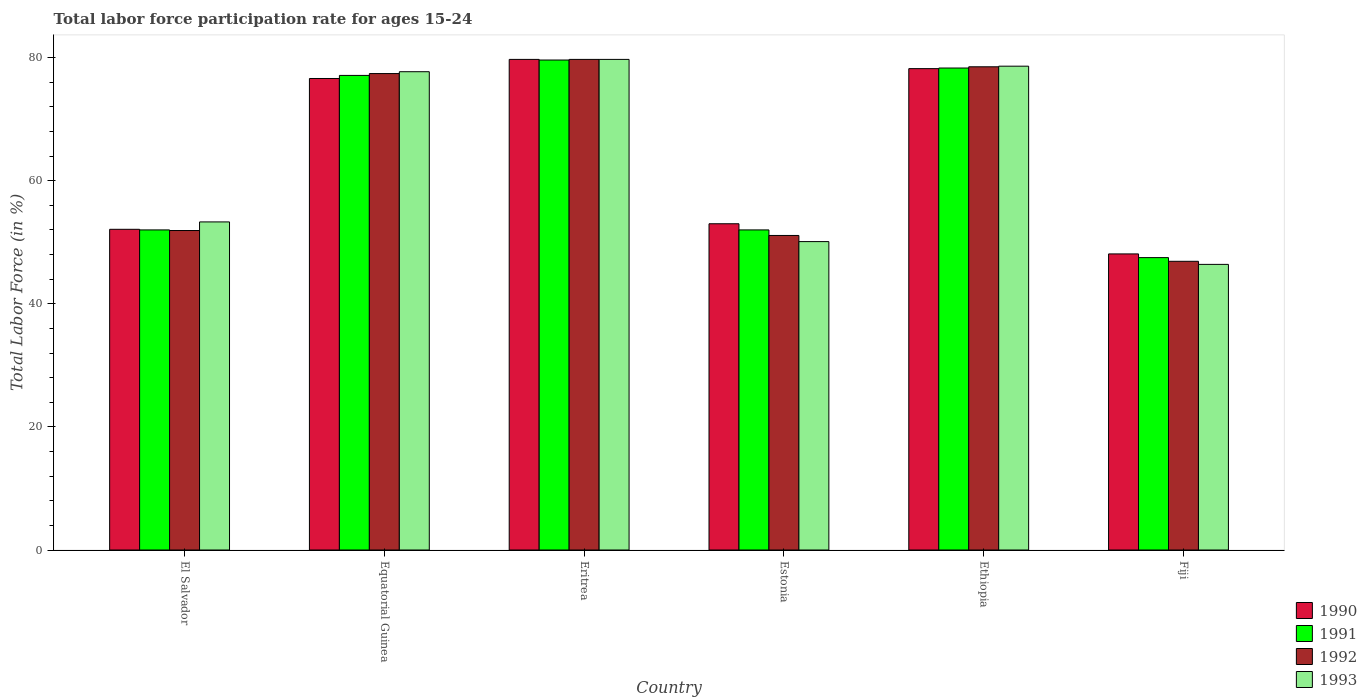How many different coloured bars are there?
Ensure brevity in your answer.  4. How many groups of bars are there?
Keep it short and to the point. 6. How many bars are there on the 1st tick from the left?
Offer a terse response. 4. How many bars are there on the 1st tick from the right?
Offer a very short reply. 4. What is the label of the 3rd group of bars from the left?
Offer a very short reply. Eritrea. In how many cases, is the number of bars for a given country not equal to the number of legend labels?
Provide a short and direct response. 0. What is the labor force participation rate in 1991 in Equatorial Guinea?
Your answer should be compact. 77.1. Across all countries, what is the maximum labor force participation rate in 1992?
Provide a short and direct response. 79.7. Across all countries, what is the minimum labor force participation rate in 1993?
Keep it short and to the point. 46.4. In which country was the labor force participation rate in 1992 maximum?
Make the answer very short. Eritrea. In which country was the labor force participation rate in 1993 minimum?
Provide a succinct answer. Fiji. What is the total labor force participation rate in 1990 in the graph?
Keep it short and to the point. 387.7. What is the difference between the labor force participation rate in 1993 in Equatorial Guinea and that in Fiji?
Provide a succinct answer. 31.3. What is the difference between the labor force participation rate in 1991 in Estonia and the labor force participation rate in 1993 in Equatorial Guinea?
Your response must be concise. -25.7. What is the average labor force participation rate in 1992 per country?
Keep it short and to the point. 64.25. What is the difference between the labor force participation rate of/in 1990 and labor force participation rate of/in 1993 in Eritrea?
Offer a terse response. 0. What is the ratio of the labor force participation rate in 1990 in Estonia to that in Ethiopia?
Your response must be concise. 0.68. Is the labor force participation rate in 1990 in El Salvador less than that in Estonia?
Your answer should be compact. Yes. What is the difference between the highest and the second highest labor force participation rate in 1990?
Provide a short and direct response. -1.6. What is the difference between the highest and the lowest labor force participation rate in 1993?
Offer a terse response. 33.3. Is the sum of the labor force participation rate in 1993 in Eritrea and Estonia greater than the maximum labor force participation rate in 1992 across all countries?
Your answer should be compact. Yes. Is it the case that in every country, the sum of the labor force participation rate in 1993 and labor force participation rate in 1991 is greater than the sum of labor force participation rate in 1990 and labor force participation rate in 1992?
Ensure brevity in your answer.  No. What does the 4th bar from the left in Fiji represents?
Offer a very short reply. 1993. Does the graph contain grids?
Provide a short and direct response. No. Where does the legend appear in the graph?
Give a very brief answer. Bottom right. How many legend labels are there?
Your answer should be very brief. 4. What is the title of the graph?
Offer a very short reply. Total labor force participation rate for ages 15-24. Does "1975" appear as one of the legend labels in the graph?
Your answer should be very brief. No. What is the label or title of the X-axis?
Keep it short and to the point. Country. What is the label or title of the Y-axis?
Keep it short and to the point. Total Labor Force (in %). What is the Total Labor Force (in %) of 1990 in El Salvador?
Your answer should be very brief. 52.1. What is the Total Labor Force (in %) in 1991 in El Salvador?
Your answer should be compact. 52. What is the Total Labor Force (in %) of 1992 in El Salvador?
Your response must be concise. 51.9. What is the Total Labor Force (in %) in 1993 in El Salvador?
Offer a terse response. 53.3. What is the Total Labor Force (in %) in 1990 in Equatorial Guinea?
Make the answer very short. 76.6. What is the Total Labor Force (in %) of 1991 in Equatorial Guinea?
Offer a terse response. 77.1. What is the Total Labor Force (in %) in 1992 in Equatorial Guinea?
Give a very brief answer. 77.4. What is the Total Labor Force (in %) of 1993 in Equatorial Guinea?
Your answer should be very brief. 77.7. What is the Total Labor Force (in %) in 1990 in Eritrea?
Provide a short and direct response. 79.7. What is the Total Labor Force (in %) of 1991 in Eritrea?
Your response must be concise. 79.6. What is the Total Labor Force (in %) of 1992 in Eritrea?
Your answer should be compact. 79.7. What is the Total Labor Force (in %) of 1993 in Eritrea?
Provide a succinct answer. 79.7. What is the Total Labor Force (in %) in 1992 in Estonia?
Offer a very short reply. 51.1. What is the Total Labor Force (in %) of 1993 in Estonia?
Your response must be concise. 50.1. What is the Total Labor Force (in %) of 1990 in Ethiopia?
Your response must be concise. 78.2. What is the Total Labor Force (in %) of 1991 in Ethiopia?
Make the answer very short. 78.3. What is the Total Labor Force (in %) in 1992 in Ethiopia?
Give a very brief answer. 78.5. What is the Total Labor Force (in %) of 1993 in Ethiopia?
Offer a terse response. 78.6. What is the Total Labor Force (in %) of 1990 in Fiji?
Give a very brief answer. 48.1. What is the Total Labor Force (in %) of 1991 in Fiji?
Provide a short and direct response. 47.5. What is the Total Labor Force (in %) in 1992 in Fiji?
Your answer should be very brief. 46.9. What is the Total Labor Force (in %) of 1993 in Fiji?
Provide a succinct answer. 46.4. Across all countries, what is the maximum Total Labor Force (in %) of 1990?
Make the answer very short. 79.7. Across all countries, what is the maximum Total Labor Force (in %) in 1991?
Your response must be concise. 79.6. Across all countries, what is the maximum Total Labor Force (in %) of 1992?
Offer a terse response. 79.7. Across all countries, what is the maximum Total Labor Force (in %) of 1993?
Provide a short and direct response. 79.7. Across all countries, what is the minimum Total Labor Force (in %) in 1990?
Make the answer very short. 48.1. Across all countries, what is the minimum Total Labor Force (in %) in 1991?
Your answer should be very brief. 47.5. Across all countries, what is the minimum Total Labor Force (in %) in 1992?
Offer a very short reply. 46.9. Across all countries, what is the minimum Total Labor Force (in %) of 1993?
Ensure brevity in your answer.  46.4. What is the total Total Labor Force (in %) in 1990 in the graph?
Keep it short and to the point. 387.7. What is the total Total Labor Force (in %) in 1991 in the graph?
Ensure brevity in your answer.  386.5. What is the total Total Labor Force (in %) of 1992 in the graph?
Ensure brevity in your answer.  385.5. What is the total Total Labor Force (in %) of 1993 in the graph?
Your answer should be very brief. 385.8. What is the difference between the Total Labor Force (in %) in 1990 in El Salvador and that in Equatorial Guinea?
Your answer should be very brief. -24.5. What is the difference between the Total Labor Force (in %) in 1991 in El Salvador and that in Equatorial Guinea?
Keep it short and to the point. -25.1. What is the difference between the Total Labor Force (in %) in 1992 in El Salvador and that in Equatorial Guinea?
Give a very brief answer. -25.5. What is the difference between the Total Labor Force (in %) in 1993 in El Salvador and that in Equatorial Guinea?
Provide a short and direct response. -24.4. What is the difference between the Total Labor Force (in %) in 1990 in El Salvador and that in Eritrea?
Offer a very short reply. -27.6. What is the difference between the Total Labor Force (in %) in 1991 in El Salvador and that in Eritrea?
Make the answer very short. -27.6. What is the difference between the Total Labor Force (in %) in 1992 in El Salvador and that in Eritrea?
Your answer should be compact. -27.8. What is the difference between the Total Labor Force (in %) of 1993 in El Salvador and that in Eritrea?
Offer a very short reply. -26.4. What is the difference between the Total Labor Force (in %) of 1990 in El Salvador and that in Estonia?
Give a very brief answer. -0.9. What is the difference between the Total Labor Force (in %) in 1991 in El Salvador and that in Estonia?
Keep it short and to the point. 0. What is the difference between the Total Labor Force (in %) of 1990 in El Salvador and that in Ethiopia?
Provide a short and direct response. -26.1. What is the difference between the Total Labor Force (in %) of 1991 in El Salvador and that in Ethiopia?
Give a very brief answer. -26.3. What is the difference between the Total Labor Force (in %) in 1992 in El Salvador and that in Ethiopia?
Give a very brief answer. -26.6. What is the difference between the Total Labor Force (in %) of 1993 in El Salvador and that in Ethiopia?
Give a very brief answer. -25.3. What is the difference between the Total Labor Force (in %) of 1991 in El Salvador and that in Fiji?
Your response must be concise. 4.5. What is the difference between the Total Labor Force (in %) of 1990 in Equatorial Guinea and that in Eritrea?
Ensure brevity in your answer.  -3.1. What is the difference between the Total Labor Force (in %) in 1991 in Equatorial Guinea and that in Eritrea?
Make the answer very short. -2.5. What is the difference between the Total Labor Force (in %) of 1992 in Equatorial Guinea and that in Eritrea?
Make the answer very short. -2.3. What is the difference between the Total Labor Force (in %) of 1993 in Equatorial Guinea and that in Eritrea?
Your response must be concise. -2. What is the difference between the Total Labor Force (in %) of 1990 in Equatorial Guinea and that in Estonia?
Keep it short and to the point. 23.6. What is the difference between the Total Labor Force (in %) in 1991 in Equatorial Guinea and that in Estonia?
Your response must be concise. 25.1. What is the difference between the Total Labor Force (in %) in 1992 in Equatorial Guinea and that in Estonia?
Ensure brevity in your answer.  26.3. What is the difference between the Total Labor Force (in %) in 1993 in Equatorial Guinea and that in Estonia?
Ensure brevity in your answer.  27.6. What is the difference between the Total Labor Force (in %) in 1990 in Equatorial Guinea and that in Ethiopia?
Provide a succinct answer. -1.6. What is the difference between the Total Labor Force (in %) of 1992 in Equatorial Guinea and that in Ethiopia?
Provide a short and direct response. -1.1. What is the difference between the Total Labor Force (in %) of 1991 in Equatorial Guinea and that in Fiji?
Give a very brief answer. 29.6. What is the difference between the Total Labor Force (in %) of 1992 in Equatorial Guinea and that in Fiji?
Offer a terse response. 30.5. What is the difference between the Total Labor Force (in %) in 1993 in Equatorial Guinea and that in Fiji?
Offer a very short reply. 31.3. What is the difference between the Total Labor Force (in %) in 1990 in Eritrea and that in Estonia?
Your response must be concise. 26.7. What is the difference between the Total Labor Force (in %) of 1991 in Eritrea and that in Estonia?
Make the answer very short. 27.6. What is the difference between the Total Labor Force (in %) of 1992 in Eritrea and that in Estonia?
Your answer should be compact. 28.6. What is the difference between the Total Labor Force (in %) of 1993 in Eritrea and that in Estonia?
Your answer should be compact. 29.6. What is the difference between the Total Labor Force (in %) in 1991 in Eritrea and that in Ethiopia?
Give a very brief answer. 1.3. What is the difference between the Total Labor Force (in %) in 1993 in Eritrea and that in Ethiopia?
Give a very brief answer. 1.1. What is the difference between the Total Labor Force (in %) in 1990 in Eritrea and that in Fiji?
Offer a terse response. 31.6. What is the difference between the Total Labor Force (in %) in 1991 in Eritrea and that in Fiji?
Your response must be concise. 32.1. What is the difference between the Total Labor Force (in %) of 1992 in Eritrea and that in Fiji?
Your answer should be very brief. 32.8. What is the difference between the Total Labor Force (in %) of 1993 in Eritrea and that in Fiji?
Provide a short and direct response. 33.3. What is the difference between the Total Labor Force (in %) of 1990 in Estonia and that in Ethiopia?
Keep it short and to the point. -25.2. What is the difference between the Total Labor Force (in %) in 1991 in Estonia and that in Ethiopia?
Provide a short and direct response. -26.3. What is the difference between the Total Labor Force (in %) of 1992 in Estonia and that in Ethiopia?
Offer a very short reply. -27.4. What is the difference between the Total Labor Force (in %) in 1993 in Estonia and that in Ethiopia?
Make the answer very short. -28.5. What is the difference between the Total Labor Force (in %) of 1990 in Estonia and that in Fiji?
Your response must be concise. 4.9. What is the difference between the Total Labor Force (in %) in 1993 in Estonia and that in Fiji?
Make the answer very short. 3.7. What is the difference between the Total Labor Force (in %) in 1990 in Ethiopia and that in Fiji?
Ensure brevity in your answer.  30.1. What is the difference between the Total Labor Force (in %) in 1991 in Ethiopia and that in Fiji?
Your answer should be very brief. 30.8. What is the difference between the Total Labor Force (in %) of 1992 in Ethiopia and that in Fiji?
Offer a terse response. 31.6. What is the difference between the Total Labor Force (in %) of 1993 in Ethiopia and that in Fiji?
Keep it short and to the point. 32.2. What is the difference between the Total Labor Force (in %) of 1990 in El Salvador and the Total Labor Force (in %) of 1992 in Equatorial Guinea?
Provide a succinct answer. -25.3. What is the difference between the Total Labor Force (in %) of 1990 in El Salvador and the Total Labor Force (in %) of 1993 in Equatorial Guinea?
Keep it short and to the point. -25.6. What is the difference between the Total Labor Force (in %) in 1991 in El Salvador and the Total Labor Force (in %) in 1992 in Equatorial Guinea?
Your response must be concise. -25.4. What is the difference between the Total Labor Force (in %) in 1991 in El Salvador and the Total Labor Force (in %) in 1993 in Equatorial Guinea?
Provide a short and direct response. -25.7. What is the difference between the Total Labor Force (in %) in 1992 in El Salvador and the Total Labor Force (in %) in 1993 in Equatorial Guinea?
Provide a short and direct response. -25.8. What is the difference between the Total Labor Force (in %) in 1990 in El Salvador and the Total Labor Force (in %) in 1991 in Eritrea?
Ensure brevity in your answer.  -27.5. What is the difference between the Total Labor Force (in %) in 1990 in El Salvador and the Total Labor Force (in %) in 1992 in Eritrea?
Your answer should be very brief. -27.6. What is the difference between the Total Labor Force (in %) in 1990 in El Salvador and the Total Labor Force (in %) in 1993 in Eritrea?
Provide a short and direct response. -27.6. What is the difference between the Total Labor Force (in %) in 1991 in El Salvador and the Total Labor Force (in %) in 1992 in Eritrea?
Provide a succinct answer. -27.7. What is the difference between the Total Labor Force (in %) in 1991 in El Salvador and the Total Labor Force (in %) in 1993 in Eritrea?
Keep it short and to the point. -27.7. What is the difference between the Total Labor Force (in %) in 1992 in El Salvador and the Total Labor Force (in %) in 1993 in Eritrea?
Offer a very short reply. -27.8. What is the difference between the Total Labor Force (in %) of 1991 in El Salvador and the Total Labor Force (in %) of 1992 in Estonia?
Your response must be concise. 0.9. What is the difference between the Total Labor Force (in %) of 1992 in El Salvador and the Total Labor Force (in %) of 1993 in Estonia?
Ensure brevity in your answer.  1.8. What is the difference between the Total Labor Force (in %) of 1990 in El Salvador and the Total Labor Force (in %) of 1991 in Ethiopia?
Make the answer very short. -26.2. What is the difference between the Total Labor Force (in %) of 1990 in El Salvador and the Total Labor Force (in %) of 1992 in Ethiopia?
Offer a terse response. -26.4. What is the difference between the Total Labor Force (in %) of 1990 in El Salvador and the Total Labor Force (in %) of 1993 in Ethiopia?
Make the answer very short. -26.5. What is the difference between the Total Labor Force (in %) of 1991 in El Salvador and the Total Labor Force (in %) of 1992 in Ethiopia?
Your response must be concise. -26.5. What is the difference between the Total Labor Force (in %) in 1991 in El Salvador and the Total Labor Force (in %) in 1993 in Ethiopia?
Keep it short and to the point. -26.6. What is the difference between the Total Labor Force (in %) of 1992 in El Salvador and the Total Labor Force (in %) of 1993 in Ethiopia?
Offer a terse response. -26.7. What is the difference between the Total Labor Force (in %) of 1990 in El Salvador and the Total Labor Force (in %) of 1991 in Fiji?
Provide a short and direct response. 4.6. What is the difference between the Total Labor Force (in %) of 1990 in El Salvador and the Total Labor Force (in %) of 1992 in Fiji?
Make the answer very short. 5.2. What is the difference between the Total Labor Force (in %) in 1990 in El Salvador and the Total Labor Force (in %) in 1993 in Fiji?
Give a very brief answer. 5.7. What is the difference between the Total Labor Force (in %) in 1991 in El Salvador and the Total Labor Force (in %) in 1992 in Fiji?
Your answer should be compact. 5.1. What is the difference between the Total Labor Force (in %) of 1992 in El Salvador and the Total Labor Force (in %) of 1993 in Fiji?
Make the answer very short. 5.5. What is the difference between the Total Labor Force (in %) in 1990 in Equatorial Guinea and the Total Labor Force (in %) in 1991 in Eritrea?
Keep it short and to the point. -3. What is the difference between the Total Labor Force (in %) in 1990 in Equatorial Guinea and the Total Labor Force (in %) in 1993 in Eritrea?
Keep it short and to the point. -3.1. What is the difference between the Total Labor Force (in %) of 1991 in Equatorial Guinea and the Total Labor Force (in %) of 1992 in Eritrea?
Your response must be concise. -2.6. What is the difference between the Total Labor Force (in %) of 1992 in Equatorial Guinea and the Total Labor Force (in %) of 1993 in Eritrea?
Your answer should be compact. -2.3. What is the difference between the Total Labor Force (in %) of 1990 in Equatorial Guinea and the Total Labor Force (in %) of 1991 in Estonia?
Keep it short and to the point. 24.6. What is the difference between the Total Labor Force (in %) of 1990 in Equatorial Guinea and the Total Labor Force (in %) of 1993 in Estonia?
Your answer should be very brief. 26.5. What is the difference between the Total Labor Force (in %) in 1991 in Equatorial Guinea and the Total Labor Force (in %) in 1993 in Estonia?
Provide a short and direct response. 27. What is the difference between the Total Labor Force (in %) in 1992 in Equatorial Guinea and the Total Labor Force (in %) in 1993 in Estonia?
Provide a succinct answer. 27.3. What is the difference between the Total Labor Force (in %) of 1990 in Equatorial Guinea and the Total Labor Force (in %) of 1992 in Ethiopia?
Your answer should be very brief. -1.9. What is the difference between the Total Labor Force (in %) in 1991 in Equatorial Guinea and the Total Labor Force (in %) in 1992 in Ethiopia?
Provide a short and direct response. -1.4. What is the difference between the Total Labor Force (in %) of 1991 in Equatorial Guinea and the Total Labor Force (in %) of 1993 in Ethiopia?
Your answer should be compact. -1.5. What is the difference between the Total Labor Force (in %) of 1992 in Equatorial Guinea and the Total Labor Force (in %) of 1993 in Ethiopia?
Give a very brief answer. -1.2. What is the difference between the Total Labor Force (in %) of 1990 in Equatorial Guinea and the Total Labor Force (in %) of 1991 in Fiji?
Ensure brevity in your answer.  29.1. What is the difference between the Total Labor Force (in %) in 1990 in Equatorial Guinea and the Total Labor Force (in %) in 1992 in Fiji?
Your answer should be very brief. 29.7. What is the difference between the Total Labor Force (in %) in 1990 in Equatorial Guinea and the Total Labor Force (in %) in 1993 in Fiji?
Keep it short and to the point. 30.2. What is the difference between the Total Labor Force (in %) of 1991 in Equatorial Guinea and the Total Labor Force (in %) of 1992 in Fiji?
Your answer should be compact. 30.2. What is the difference between the Total Labor Force (in %) of 1991 in Equatorial Guinea and the Total Labor Force (in %) of 1993 in Fiji?
Provide a short and direct response. 30.7. What is the difference between the Total Labor Force (in %) of 1992 in Equatorial Guinea and the Total Labor Force (in %) of 1993 in Fiji?
Your answer should be very brief. 31. What is the difference between the Total Labor Force (in %) in 1990 in Eritrea and the Total Labor Force (in %) in 1991 in Estonia?
Keep it short and to the point. 27.7. What is the difference between the Total Labor Force (in %) of 1990 in Eritrea and the Total Labor Force (in %) of 1992 in Estonia?
Offer a very short reply. 28.6. What is the difference between the Total Labor Force (in %) in 1990 in Eritrea and the Total Labor Force (in %) in 1993 in Estonia?
Your answer should be compact. 29.6. What is the difference between the Total Labor Force (in %) in 1991 in Eritrea and the Total Labor Force (in %) in 1993 in Estonia?
Make the answer very short. 29.5. What is the difference between the Total Labor Force (in %) in 1992 in Eritrea and the Total Labor Force (in %) in 1993 in Estonia?
Your answer should be compact. 29.6. What is the difference between the Total Labor Force (in %) in 1990 in Eritrea and the Total Labor Force (in %) in 1991 in Ethiopia?
Your answer should be compact. 1.4. What is the difference between the Total Labor Force (in %) in 1990 in Eritrea and the Total Labor Force (in %) in 1992 in Ethiopia?
Your answer should be compact. 1.2. What is the difference between the Total Labor Force (in %) in 1991 in Eritrea and the Total Labor Force (in %) in 1993 in Ethiopia?
Keep it short and to the point. 1. What is the difference between the Total Labor Force (in %) in 1992 in Eritrea and the Total Labor Force (in %) in 1993 in Ethiopia?
Provide a succinct answer. 1.1. What is the difference between the Total Labor Force (in %) in 1990 in Eritrea and the Total Labor Force (in %) in 1991 in Fiji?
Keep it short and to the point. 32.2. What is the difference between the Total Labor Force (in %) in 1990 in Eritrea and the Total Labor Force (in %) in 1992 in Fiji?
Ensure brevity in your answer.  32.8. What is the difference between the Total Labor Force (in %) in 1990 in Eritrea and the Total Labor Force (in %) in 1993 in Fiji?
Give a very brief answer. 33.3. What is the difference between the Total Labor Force (in %) of 1991 in Eritrea and the Total Labor Force (in %) of 1992 in Fiji?
Offer a very short reply. 32.7. What is the difference between the Total Labor Force (in %) in 1991 in Eritrea and the Total Labor Force (in %) in 1993 in Fiji?
Keep it short and to the point. 33.2. What is the difference between the Total Labor Force (in %) in 1992 in Eritrea and the Total Labor Force (in %) in 1993 in Fiji?
Your answer should be very brief. 33.3. What is the difference between the Total Labor Force (in %) of 1990 in Estonia and the Total Labor Force (in %) of 1991 in Ethiopia?
Keep it short and to the point. -25.3. What is the difference between the Total Labor Force (in %) of 1990 in Estonia and the Total Labor Force (in %) of 1992 in Ethiopia?
Provide a succinct answer. -25.5. What is the difference between the Total Labor Force (in %) of 1990 in Estonia and the Total Labor Force (in %) of 1993 in Ethiopia?
Your response must be concise. -25.6. What is the difference between the Total Labor Force (in %) of 1991 in Estonia and the Total Labor Force (in %) of 1992 in Ethiopia?
Offer a very short reply. -26.5. What is the difference between the Total Labor Force (in %) in 1991 in Estonia and the Total Labor Force (in %) in 1993 in Ethiopia?
Offer a very short reply. -26.6. What is the difference between the Total Labor Force (in %) of 1992 in Estonia and the Total Labor Force (in %) of 1993 in Ethiopia?
Your answer should be very brief. -27.5. What is the difference between the Total Labor Force (in %) in 1990 in Ethiopia and the Total Labor Force (in %) in 1991 in Fiji?
Ensure brevity in your answer.  30.7. What is the difference between the Total Labor Force (in %) of 1990 in Ethiopia and the Total Labor Force (in %) of 1992 in Fiji?
Ensure brevity in your answer.  31.3. What is the difference between the Total Labor Force (in %) in 1990 in Ethiopia and the Total Labor Force (in %) in 1993 in Fiji?
Your response must be concise. 31.8. What is the difference between the Total Labor Force (in %) of 1991 in Ethiopia and the Total Labor Force (in %) of 1992 in Fiji?
Offer a very short reply. 31.4. What is the difference between the Total Labor Force (in %) in 1991 in Ethiopia and the Total Labor Force (in %) in 1993 in Fiji?
Your answer should be compact. 31.9. What is the difference between the Total Labor Force (in %) in 1992 in Ethiopia and the Total Labor Force (in %) in 1993 in Fiji?
Provide a short and direct response. 32.1. What is the average Total Labor Force (in %) of 1990 per country?
Your answer should be very brief. 64.62. What is the average Total Labor Force (in %) of 1991 per country?
Offer a terse response. 64.42. What is the average Total Labor Force (in %) in 1992 per country?
Your answer should be very brief. 64.25. What is the average Total Labor Force (in %) in 1993 per country?
Give a very brief answer. 64.3. What is the difference between the Total Labor Force (in %) of 1990 and Total Labor Force (in %) of 1992 in El Salvador?
Give a very brief answer. 0.2. What is the difference between the Total Labor Force (in %) in 1991 and Total Labor Force (in %) in 1992 in El Salvador?
Your answer should be compact. 0.1. What is the difference between the Total Labor Force (in %) of 1991 and Total Labor Force (in %) of 1993 in El Salvador?
Make the answer very short. -1.3. What is the difference between the Total Labor Force (in %) of 1992 and Total Labor Force (in %) of 1993 in El Salvador?
Keep it short and to the point. -1.4. What is the difference between the Total Labor Force (in %) in 1990 and Total Labor Force (in %) in 1993 in Equatorial Guinea?
Provide a short and direct response. -1.1. What is the difference between the Total Labor Force (in %) in 1991 and Total Labor Force (in %) in 1993 in Equatorial Guinea?
Provide a short and direct response. -0.6. What is the difference between the Total Labor Force (in %) in 1992 and Total Labor Force (in %) in 1993 in Equatorial Guinea?
Your answer should be compact. -0.3. What is the difference between the Total Labor Force (in %) of 1990 and Total Labor Force (in %) of 1991 in Eritrea?
Keep it short and to the point. 0.1. What is the difference between the Total Labor Force (in %) of 1991 and Total Labor Force (in %) of 1992 in Eritrea?
Ensure brevity in your answer.  -0.1. What is the difference between the Total Labor Force (in %) in 1991 and Total Labor Force (in %) in 1993 in Eritrea?
Your response must be concise. -0.1. What is the difference between the Total Labor Force (in %) of 1992 and Total Labor Force (in %) of 1993 in Eritrea?
Ensure brevity in your answer.  0. What is the difference between the Total Labor Force (in %) of 1990 and Total Labor Force (in %) of 1992 in Estonia?
Your answer should be compact. 1.9. What is the difference between the Total Labor Force (in %) of 1991 and Total Labor Force (in %) of 1992 in Estonia?
Offer a terse response. 0.9. What is the difference between the Total Labor Force (in %) in 1990 and Total Labor Force (in %) in 1991 in Ethiopia?
Make the answer very short. -0.1. What is the difference between the Total Labor Force (in %) of 1990 and Total Labor Force (in %) of 1992 in Ethiopia?
Keep it short and to the point. -0.3. What is the difference between the Total Labor Force (in %) in 1992 and Total Labor Force (in %) in 1993 in Ethiopia?
Provide a short and direct response. -0.1. What is the difference between the Total Labor Force (in %) in 1991 and Total Labor Force (in %) in 1992 in Fiji?
Your answer should be very brief. 0.6. What is the difference between the Total Labor Force (in %) in 1992 and Total Labor Force (in %) in 1993 in Fiji?
Your answer should be compact. 0.5. What is the ratio of the Total Labor Force (in %) of 1990 in El Salvador to that in Equatorial Guinea?
Offer a terse response. 0.68. What is the ratio of the Total Labor Force (in %) of 1991 in El Salvador to that in Equatorial Guinea?
Ensure brevity in your answer.  0.67. What is the ratio of the Total Labor Force (in %) in 1992 in El Salvador to that in Equatorial Guinea?
Provide a short and direct response. 0.67. What is the ratio of the Total Labor Force (in %) in 1993 in El Salvador to that in Equatorial Guinea?
Offer a very short reply. 0.69. What is the ratio of the Total Labor Force (in %) in 1990 in El Salvador to that in Eritrea?
Offer a very short reply. 0.65. What is the ratio of the Total Labor Force (in %) in 1991 in El Salvador to that in Eritrea?
Your answer should be very brief. 0.65. What is the ratio of the Total Labor Force (in %) in 1992 in El Salvador to that in Eritrea?
Provide a short and direct response. 0.65. What is the ratio of the Total Labor Force (in %) in 1993 in El Salvador to that in Eritrea?
Ensure brevity in your answer.  0.67. What is the ratio of the Total Labor Force (in %) of 1990 in El Salvador to that in Estonia?
Provide a succinct answer. 0.98. What is the ratio of the Total Labor Force (in %) of 1992 in El Salvador to that in Estonia?
Keep it short and to the point. 1.02. What is the ratio of the Total Labor Force (in %) of 1993 in El Salvador to that in Estonia?
Your answer should be very brief. 1.06. What is the ratio of the Total Labor Force (in %) in 1990 in El Salvador to that in Ethiopia?
Keep it short and to the point. 0.67. What is the ratio of the Total Labor Force (in %) in 1991 in El Salvador to that in Ethiopia?
Your answer should be compact. 0.66. What is the ratio of the Total Labor Force (in %) in 1992 in El Salvador to that in Ethiopia?
Offer a very short reply. 0.66. What is the ratio of the Total Labor Force (in %) of 1993 in El Salvador to that in Ethiopia?
Offer a terse response. 0.68. What is the ratio of the Total Labor Force (in %) of 1990 in El Salvador to that in Fiji?
Your answer should be very brief. 1.08. What is the ratio of the Total Labor Force (in %) in 1991 in El Salvador to that in Fiji?
Offer a terse response. 1.09. What is the ratio of the Total Labor Force (in %) of 1992 in El Salvador to that in Fiji?
Your response must be concise. 1.11. What is the ratio of the Total Labor Force (in %) in 1993 in El Salvador to that in Fiji?
Your response must be concise. 1.15. What is the ratio of the Total Labor Force (in %) of 1990 in Equatorial Guinea to that in Eritrea?
Ensure brevity in your answer.  0.96. What is the ratio of the Total Labor Force (in %) of 1991 in Equatorial Guinea to that in Eritrea?
Provide a succinct answer. 0.97. What is the ratio of the Total Labor Force (in %) of 1992 in Equatorial Guinea to that in Eritrea?
Provide a short and direct response. 0.97. What is the ratio of the Total Labor Force (in %) in 1993 in Equatorial Guinea to that in Eritrea?
Provide a short and direct response. 0.97. What is the ratio of the Total Labor Force (in %) of 1990 in Equatorial Guinea to that in Estonia?
Ensure brevity in your answer.  1.45. What is the ratio of the Total Labor Force (in %) of 1991 in Equatorial Guinea to that in Estonia?
Your response must be concise. 1.48. What is the ratio of the Total Labor Force (in %) in 1992 in Equatorial Guinea to that in Estonia?
Provide a short and direct response. 1.51. What is the ratio of the Total Labor Force (in %) in 1993 in Equatorial Guinea to that in Estonia?
Offer a very short reply. 1.55. What is the ratio of the Total Labor Force (in %) in 1990 in Equatorial Guinea to that in Ethiopia?
Offer a terse response. 0.98. What is the ratio of the Total Labor Force (in %) of 1991 in Equatorial Guinea to that in Ethiopia?
Offer a very short reply. 0.98. What is the ratio of the Total Labor Force (in %) of 1992 in Equatorial Guinea to that in Ethiopia?
Your answer should be very brief. 0.99. What is the ratio of the Total Labor Force (in %) in 1990 in Equatorial Guinea to that in Fiji?
Your answer should be very brief. 1.59. What is the ratio of the Total Labor Force (in %) of 1991 in Equatorial Guinea to that in Fiji?
Give a very brief answer. 1.62. What is the ratio of the Total Labor Force (in %) in 1992 in Equatorial Guinea to that in Fiji?
Provide a succinct answer. 1.65. What is the ratio of the Total Labor Force (in %) of 1993 in Equatorial Guinea to that in Fiji?
Make the answer very short. 1.67. What is the ratio of the Total Labor Force (in %) of 1990 in Eritrea to that in Estonia?
Ensure brevity in your answer.  1.5. What is the ratio of the Total Labor Force (in %) of 1991 in Eritrea to that in Estonia?
Give a very brief answer. 1.53. What is the ratio of the Total Labor Force (in %) in 1992 in Eritrea to that in Estonia?
Your answer should be compact. 1.56. What is the ratio of the Total Labor Force (in %) in 1993 in Eritrea to that in Estonia?
Offer a terse response. 1.59. What is the ratio of the Total Labor Force (in %) in 1990 in Eritrea to that in Ethiopia?
Your answer should be very brief. 1.02. What is the ratio of the Total Labor Force (in %) in 1991 in Eritrea to that in Ethiopia?
Offer a terse response. 1.02. What is the ratio of the Total Labor Force (in %) in 1992 in Eritrea to that in Ethiopia?
Give a very brief answer. 1.02. What is the ratio of the Total Labor Force (in %) in 1990 in Eritrea to that in Fiji?
Ensure brevity in your answer.  1.66. What is the ratio of the Total Labor Force (in %) of 1991 in Eritrea to that in Fiji?
Give a very brief answer. 1.68. What is the ratio of the Total Labor Force (in %) in 1992 in Eritrea to that in Fiji?
Give a very brief answer. 1.7. What is the ratio of the Total Labor Force (in %) of 1993 in Eritrea to that in Fiji?
Provide a succinct answer. 1.72. What is the ratio of the Total Labor Force (in %) in 1990 in Estonia to that in Ethiopia?
Your answer should be compact. 0.68. What is the ratio of the Total Labor Force (in %) in 1991 in Estonia to that in Ethiopia?
Your response must be concise. 0.66. What is the ratio of the Total Labor Force (in %) of 1992 in Estonia to that in Ethiopia?
Offer a terse response. 0.65. What is the ratio of the Total Labor Force (in %) of 1993 in Estonia to that in Ethiopia?
Your answer should be very brief. 0.64. What is the ratio of the Total Labor Force (in %) in 1990 in Estonia to that in Fiji?
Make the answer very short. 1.1. What is the ratio of the Total Labor Force (in %) of 1991 in Estonia to that in Fiji?
Your answer should be compact. 1.09. What is the ratio of the Total Labor Force (in %) in 1992 in Estonia to that in Fiji?
Provide a succinct answer. 1.09. What is the ratio of the Total Labor Force (in %) in 1993 in Estonia to that in Fiji?
Give a very brief answer. 1.08. What is the ratio of the Total Labor Force (in %) in 1990 in Ethiopia to that in Fiji?
Make the answer very short. 1.63. What is the ratio of the Total Labor Force (in %) in 1991 in Ethiopia to that in Fiji?
Provide a succinct answer. 1.65. What is the ratio of the Total Labor Force (in %) in 1992 in Ethiopia to that in Fiji?
Ensure brevity in your answer.  1.67. What is the ratio of the Total Labor Force (in %) of 1993 in Ethiopia to that in Fiji?
Provide a short and direct response. 1.69. What is the difference between the highest and the second highest Total Labor Force (in %) in 1991?
Provide a short and direct response. 1.3. What is the difference between the highest and the second highest Total Labor Force (in %) in 1993?
Your answer should be very brief. 1.1. What is the difference between the highest and the lowest Total Labor Force (in %) in 1990?
Your response must be concise. 31.6. What is the difference between the highest and the lowest Total Labor Force (in %) in 1991?
Keep it short and to the point. 32.1. What is the difference between the highest and the lowest Total Labor Force (in %) of 1992?
Offer a very short reply. 32.8. What is the difference between the highest and the lowest Total Labor Force (in %) of 1993?
Your answer should be very brief. 33.3. 